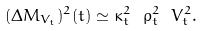Convert formula to latex. <formula><loc_0><loc_0><loc_500><loc_500>( \Delta M _ { V _ { t } } ) ^ { 2 } ( t ) \simeq \kappa ^ { 2 } _ { t } \ \rho ^ { 2 } _ { t } \ V ^ { 2 } _ { t } .</formula> 